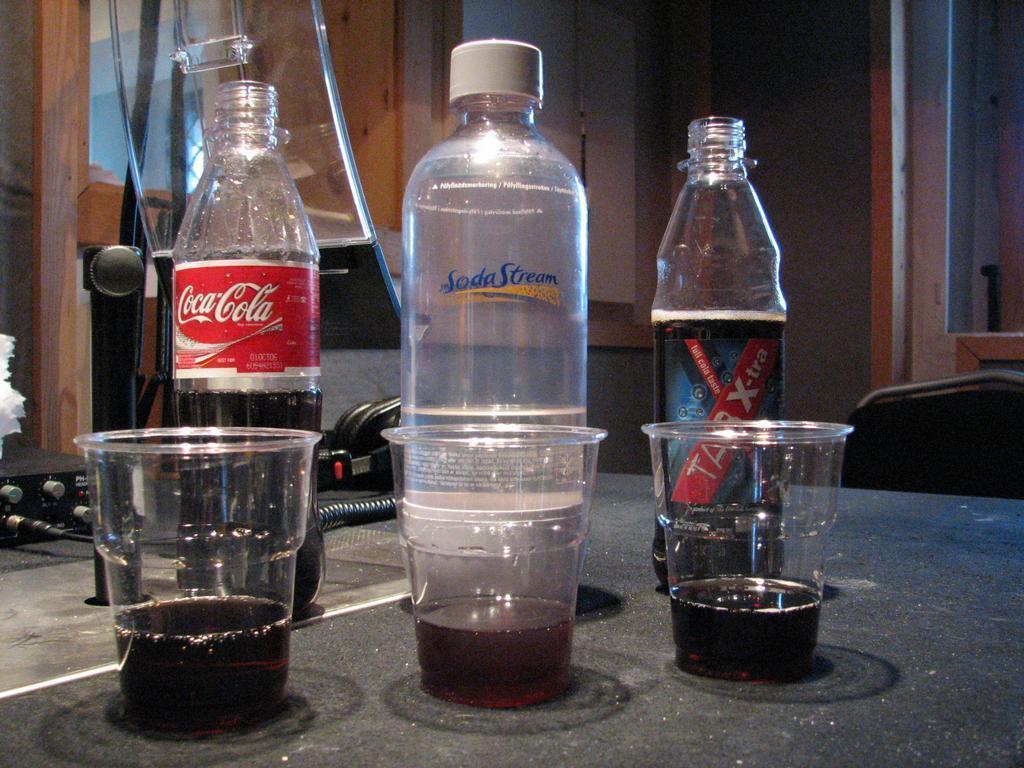In one or two sentences, can you explain what this image depicts? There are three bottles and three cups are kept on a table. In the background there is a mic, receivers, wires, and also there is a wall. 